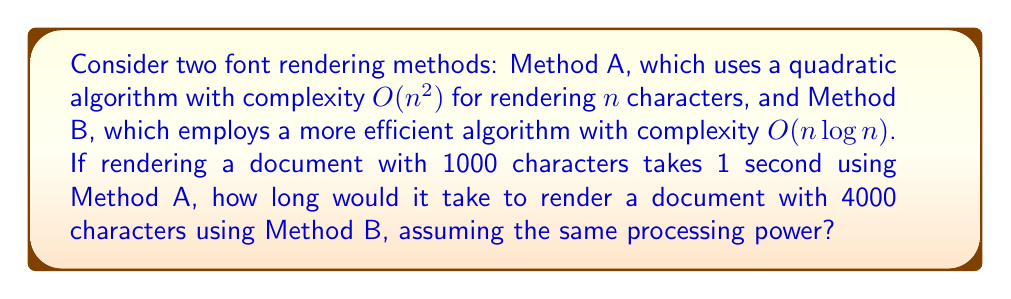Help me with this question. To solve this problem, we need to follow these steps:

1. Understand the given information:
   - Method A: $O(n^2)$
   - Method B: $O(n \log n)$
   - 1000 characters take 1 second with Method A
   - We need to find the time for 4000 characters with Method B

2. Find the constant factor for Method A:
   Let $c$ be the constant factor.
   $$c \cdot 1000^2 = 1 \text{ second}$$
   $$c = \frac{1}{1000^2} = 10^{-6} \text{ seconds}$$

3. Calculate the time for 4000 characters using Method A:
   $$t_A = 10^{-6} \cdot 4000^2 = 16 \text{ seconds}$$

4. Calculate the ratio of efficiencies between Methods A and B:
   $$\frac{\text{Method A}}{\text{Method B}} = \frac{n^2}{n \log n} = \frac{n}{\log n}$$

5. For $n = 4000$:
   $$\frac{4000}{\log 4000} \approx 331.85$$

6. Calculate the time for Method B:
   $$t_B = \frac{16}{331.85} \approx 0.0482 \text{ seconds}$$

Therefore, rendering 4000 characters using Method B would take approximately 0.0482 seconds.
Answer: $0.0482 \text{ seconds}$ 